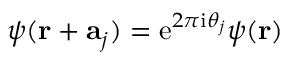<formula> <loc_0><loc_0><loc_500><loc_500>\psi ( r + a _ { j } ) = e ^ { 2 \pi i \theta _ { j } } \psi ( r )</formula> 